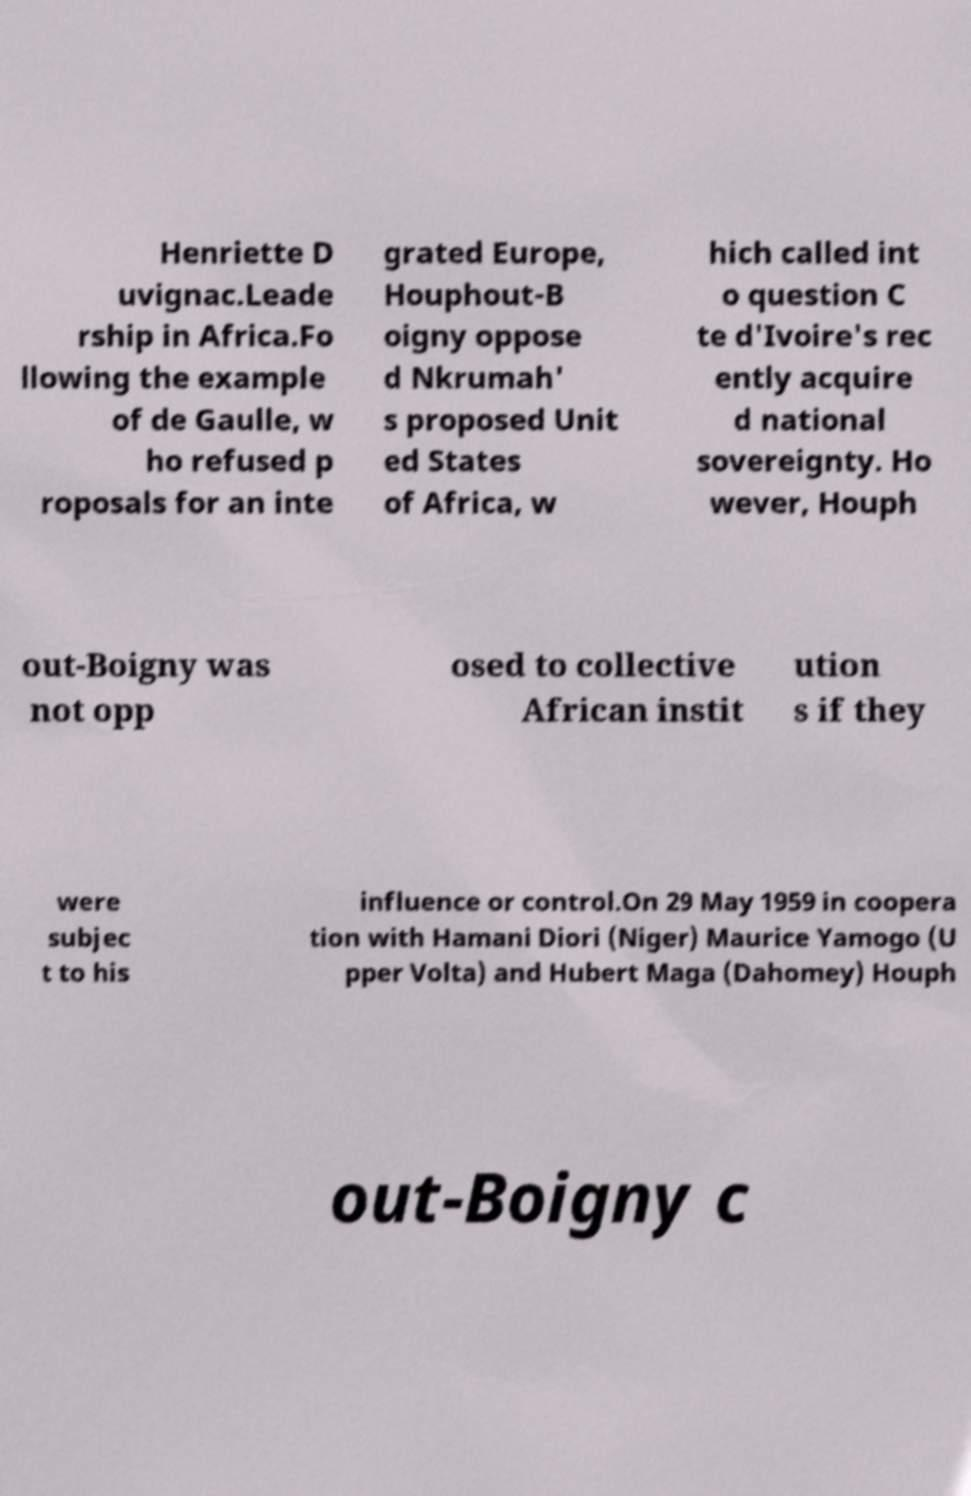Could you assist in decoding the text presented in this image and type it out clearly? Henriette D uvignac.Leade rship in Africa.Fo llowing the example of de Gaulle, w ho refused p roposals for an inte grated Europe, Houphout-B oigny oppose d Nkrumah' s proposed Unit ed States of Africa, w hich called int o question C te d'Ivoire's rec ently acquire d national sovereignty. Ho wever, Houph out-Boigny was not opp osed to collective African instit ution s if they were subjec t to his influence or control.On 29 May 1959 in coopera tion with Hamani Diori (Niger) Maurice Yamogo (U pper Volta) and Hubert Maga (Dahomey) Houph out-Boigny c 